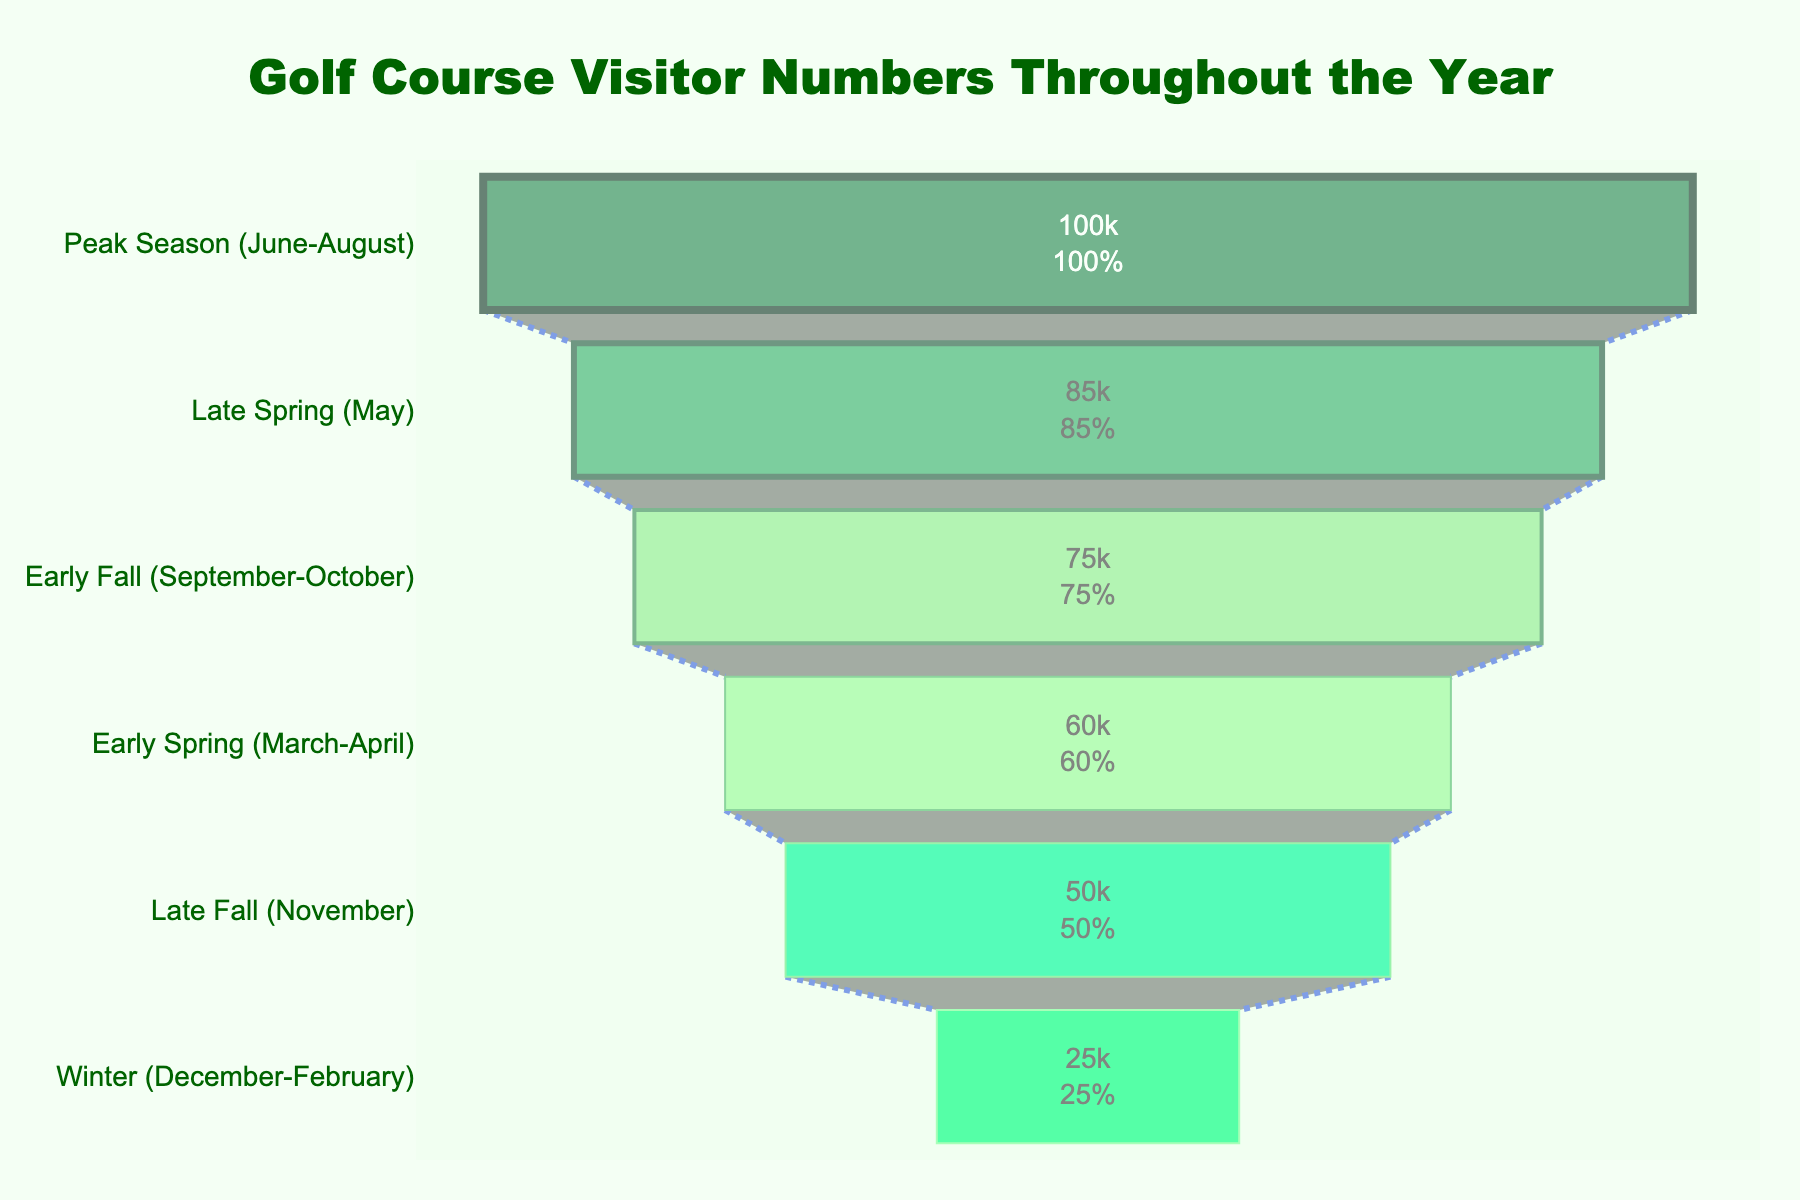What is the peak season for golf course visitors based on the funnel chart? The funnel chart indicates that the peak season for golf course visitors is represented by the stage with the highest number of visitors. According to the chart, the "Peak Season (June-August)" stage has the highest number of visitors.
Answer: Peak Season (June-August) How many visitors are there in the Early Spring stage? By looking at the funnel chart, the stage labeled "Early Spring (March-April)" shows the visitor count. According to the chart, the Early Spring stage has 60,000 visitors.
Answer: 60,000 Which stage has the lowest number of golf course visitors? The stage with the least number of visitors can be found by identifying the smallest segment in the funnel chart. According to the chart, the "Winter (December-February)" stage has the lowest number of visitors.
Answer: Winter (December-February) What is the difference in visitor numbers between Late Fall and Late Spring? To find the difference, locate the visitor counts for Late Fall and Late Spring on the chart. Late Fall has 50,000 visitors and Late Spring has 85,000 visitors. The difference is 85,000 - 50,000.
Answer: 35,000 During which stage do the visitor numbers drop most markedly from the previous stage? To determine the sharpest decline, compare the visitor numbers between consecutive stages. The most marked drop is from Late Spring (85,000) to Early Fall (75,000), which is 10,000 visitors.
Answer: From Peak Season to Early Fall Calculate the total number of visitors throughout the year. Sum the visitor numbers for all the stages shown in the funnel chart: 100,000 (Peak Season) + 85,000 (Early Fall) + 75,000 (Late Spring) + 60,000 (Early Spring) + 50,000 (Late Fall) + 25,000 (Winter).
Answer: 395,000 What percentage of the total annual visitors come during the Late Spring stage? To find the percentage, divide the number of visitors in the Late Spring stage by the total visitors for the year and multiply by 100. The calculation is (85,000 / 395,000) * 100.
Answer: 21.52% Which three stages have the highest visitor counts? Identify the top three stages by their visitor numbers as shown in the funnel chart. The highest counts are: Peak Season (100,000), Late Spring (85,000), and Early Fall (75,000).
Answer: Peak Season, Late Spring, Early Fall What is the average number of visitors across all stages? Calculate the average by summing all visitor numbers and dividing by the number of stages: (100,000 + 85,000 + 75,000 + 60,000 + 50,000 + 25,000) / 6.
Answer: 65,833 